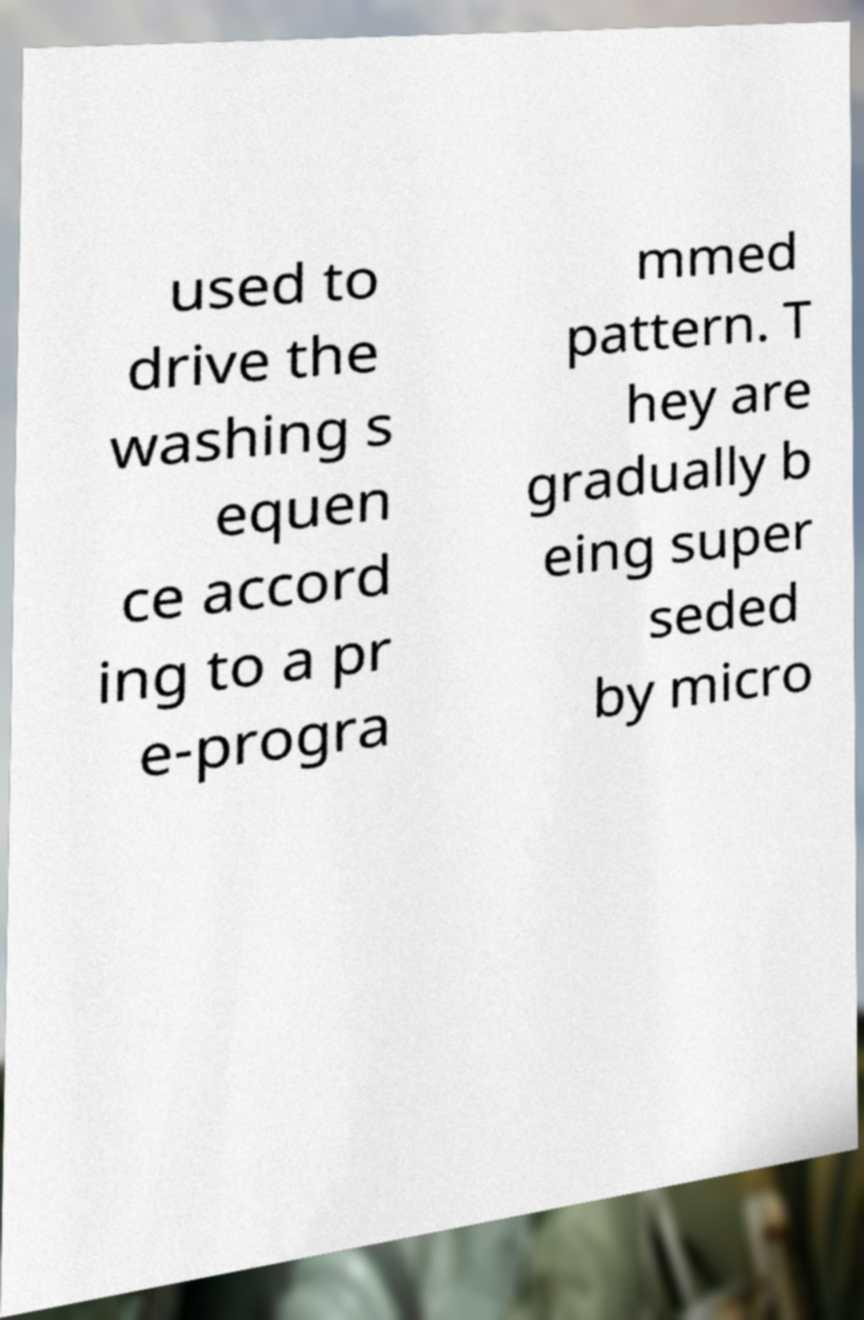Could you assist in decoding the text presented in this image and type it out clearly? used to drive the washing s equen ce accord ing to a pr e-progra mmed pattern. T hey are gradually b eing super seded by micro 